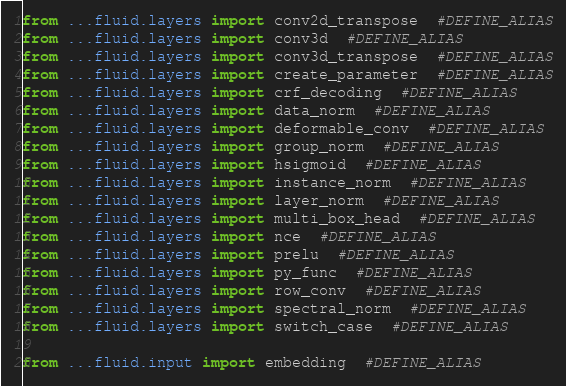<code> <loc_0><loc_0><loc_500><loc_500><_Python_>from ...fluid.layers import conv2d_transpose  #DEFINE_ALIAS
from ...fluid.layers import conv3d  #DEFINE_ALIAS
from ...fluid.layers import conv3d_transpose  #DEFINE_ALIAS
from ...fluid.layers import create_parameter  #DEFINE_ALIAS
from ...fluid.layers import crf_decoding  #DEFINE_ALIAS
from ...fluid.layers import data_norm  #DEFINE_ALIAS
from ...fluid.layers import deformable_conv  #DEFINE_ALIAS
from ...fluid.layers import group_norm  #DEFINE_ALIAS
from ...fluid.layers import hsigmoid  #DEFINE_ALIAS
from ...fluid.layers import instance_norm  #DEFINE_ALIAS
from ...fluid.layers import layer_norm  #DEFINE_ALIAS
from ...fluid.layers import multi_box_head  #DEFINE_ALIAS
from ...fluid.layers import nce  #DEFINE_ALIAS
from ...fluid.layers import prelu  #DEFINE_ALIAS
from ...fluid.layers import py_func  #DEFINE_ALIAS
from ...fluid.layers import row_conv  #DEFINE_ALIAS
from ...fluid.layers import spectral_norm  #DEFINE_ALIAS
from ...fluid.layers import switch_case  #DEFINE_ALIAS

from ...fluid.input import embedding  #DEFINE_ALIAS
</code> 